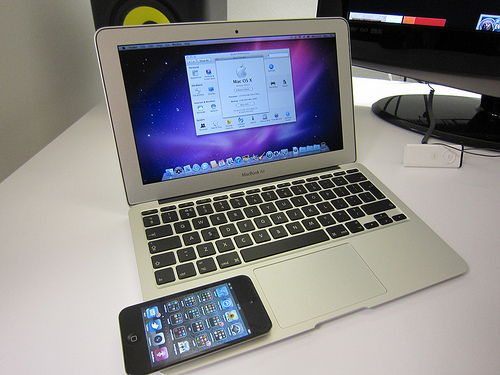<image>
Is there a phone on the computer? Yes. Looking at the image, I can see the phone is positioned on top of the computer, with the computer providing support. Where is the phone in relation to the computer? Is it next to the computer? No. The phone is not positioned next to the computer. They are located in different areas of the scene. 